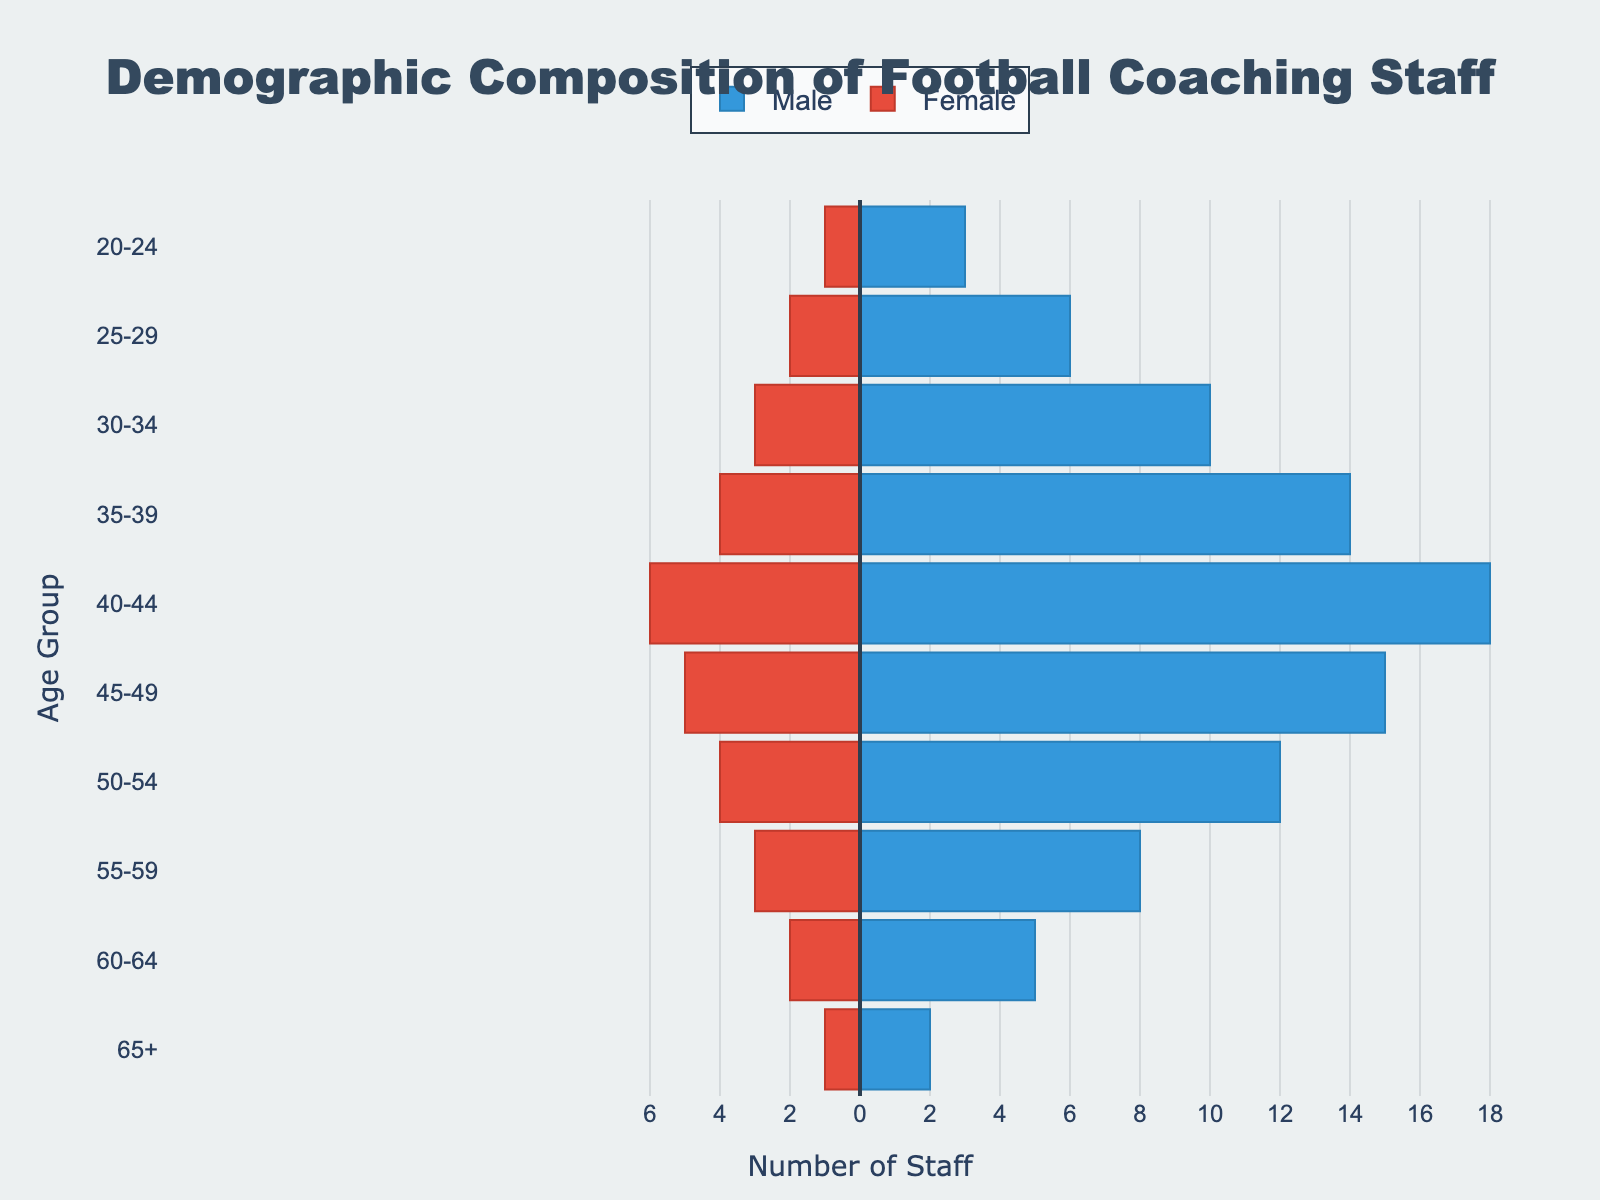What's the title of the figure? The title is usually prominently displayed at the top center of the figure. It briefly describes the content of the plot. In this case, the title reads "Demographic Composition of Football Coaching Staff".
Answer: Demographic Composition of Football Coaching Staff What does the horizontal axis represent? The horizontal axis typically indicates a measurement or count relevant to the data. Here, it represents "Number of Staff".
Answer: Number of Staff In which age group is there the highest number of male coaches? The distribution of male coaches by age group is shown using horizontal bars on the right side of the vertical central line. The age group with the longest bar represents the highest number. Here, the age group "40-44" has the longest bar for male coaches.
Answer: 40-44 Which age group has more female coaches, "25-29" or "30-34"? To compare, look at the lengths of the bars for female coaches in the "25-29" and "30-34" age groups. The group with the longer bar has more staff. The "25-29" group has 2, whereas the "30-34" has 3 (all negative values representing female coaches). Therefore, "30-34" has more female coaches.
Answer: 30-34 How many more male coaches are there in the "45-49" age group compared to the "65+" group? First, note the number of male coaches in both age groups: "45-49" has 15 and "65+" has 2. Subtract the latter from the former to find the difference (15 - 2 = 13).
Answer: 13 What is the gender ratio for the "35-39" age group? The gender ratio can be found by dividing the number of male coaches by the number of female coaches. For "35-39", there are 14 males and 4 females. Therefore, the ratio is 14/4. Simplifying it results in 3.5.
Answer: 3.5 Which age group has an equal number of male and female coaches? By examining the bars, we see that no age group has bars of equal length once absolute values are considered. Thus, no age group has an equal number of male and female coaches.
Answer: None Is there any age group where the number of female coaches exceeds that of male coaches? By reviewing the bars, it is clear that in all age groups, the number of male coaches (right-side positive bars) is higher than that of female coaches (left-side negative bars). Hence, there is no age group where females exceed males.
Answer: No 